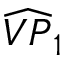Convert formula to latex. <formula><loc_0><loc_0><loc_500><loc_500>\widehat { V P } _ { 1 }</formula> 